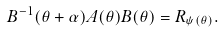<formula> <loc_0><loc_0><loc_500><loc_500>B ^ { - 1 } ( \theta + \alpha ) A ( \theta ) B ( \theta ) = R _ { \psi ( \theta ) } .</formula> 